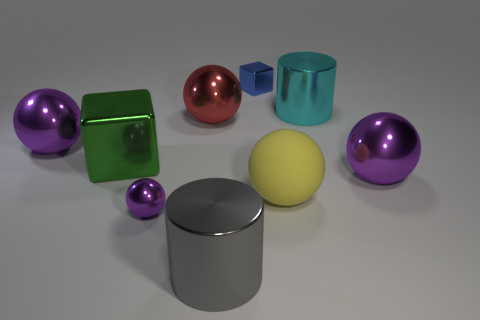There is a blue thing that is the same material as the tiny purple object; what shape is it?
Keep it short and to the point. Cube. How many matte things are either small brown cylinders or big cyan cylinders?
Your response must be concise. 0. There is a large metallic cylinder to the right of the yellow rubber sphere in front of the cyan metallic cylinder; how many large cyan metallic cylinders are on the right side of it?
Provide a short and direct response. 0. There is a shiny cylinder on the left side of the blue metallic block; is its size the same as the purple shiny thing that is in front of the large matte object?
Offer a terse response. No. There is a big cyan object that is the same shape as the large gray metallic thing; what material is it?
Keep it short and to the point. Metal. What number of small things are either matte objects or blue cylinders?
Your answer should be very brief. 0. What is the small purple ball made of?
Offer a terse response. Metal. What is the material of the large ball that is both to the left of the big cyan cylinder and on the right side of the big red thing?
Make the answer very short. Rubber. There is a tiny ball; is it the same color as the big metallic ball that is on the left side of the red metallic thing?
Your answer should be compact. Yes. There is a yellow ball that is the same size as the red shiny thing; what is it made of?
Give a very brief answer. Rubber. 